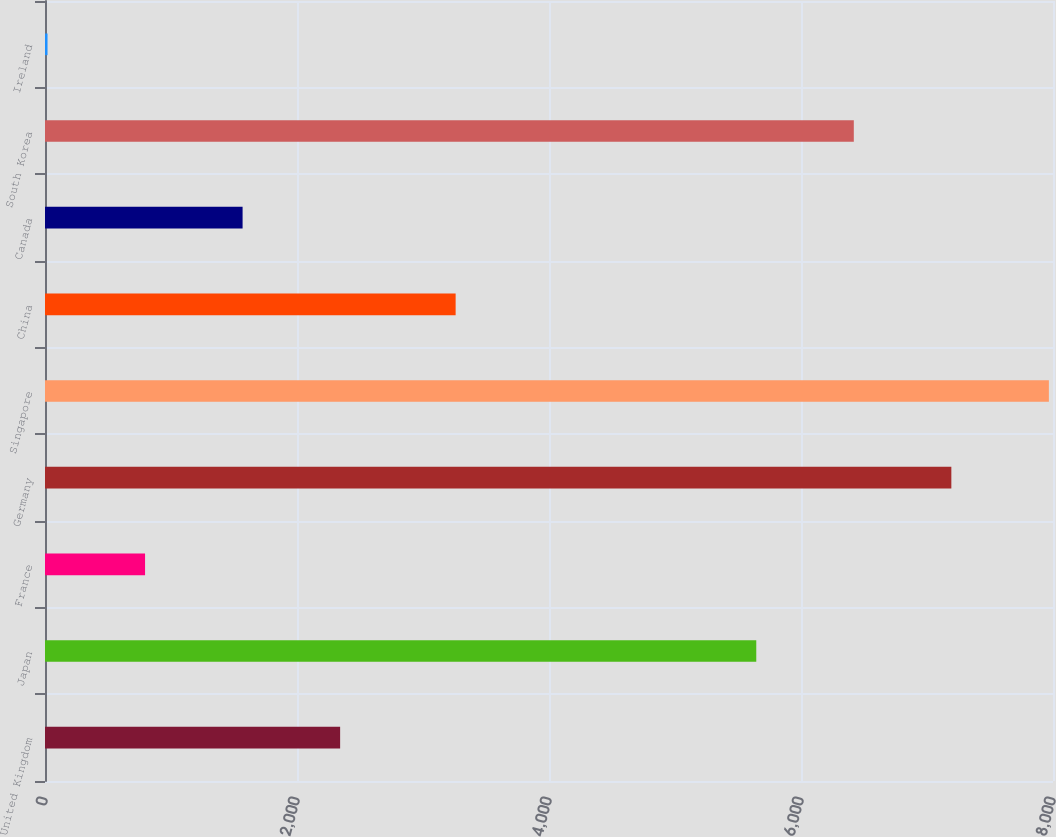Convert chart. <chart><loc_0><loc_0><loc_500><loc_500><bar_chart><fcel>United Kingdom<fcel>Japan<fcel>France<fcel>Germany<fcel>Singapore<fcel>China<fcel>Canada<fcel>South Korea<fcel>Ireland<nl><fcel>2342.3<fcel>5645<fcel>794.1<fcel>7193.2<fcel>7967.3<fcel>3259<fcel>1568.2<fcel>6419.1<fcel>20<nl></chart> 